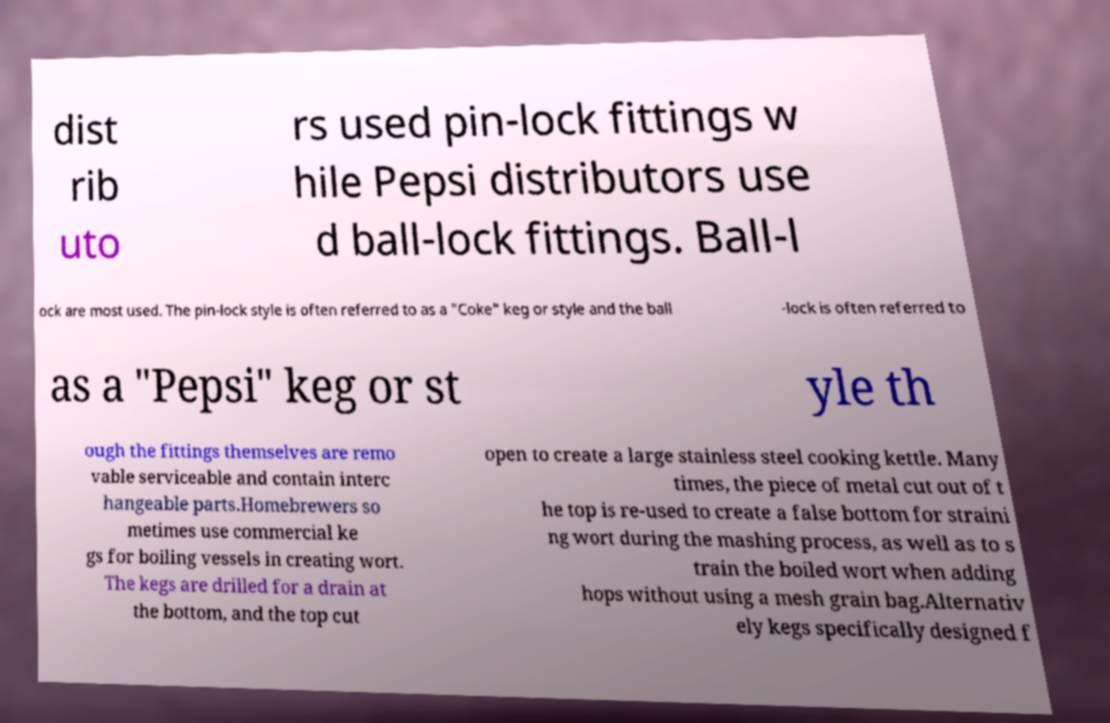What messages or text are displayed in this image? I need them in a readable, typed format. dist rib uto rs used pin-lock fittings w hile Pepsi distributors use d ball-lock fittings. Ball-l ock are most used. The pin-lock style is often referred to as a "Coke" keg or style and the ball -lock is often referred to as a "Pepsi" keg or st yle th ough the fittings themselves are remo vable serviceable and contain interc hangeable parts.Homebrewers so metimes use commercial ke gs for boiling vessels in creating wort. The kegs are drilled for a drain at the bottom, and the top cut open to create a large stainless steel cooking kettle. Many times, the piece of metal cut out of t he top is re-used to create a false bottom for straini ng wort during the mashing process, as well as to s train the boiled wort when adding hops without using a mesh grain bag.Alternativ ely kegs specifically designed f 